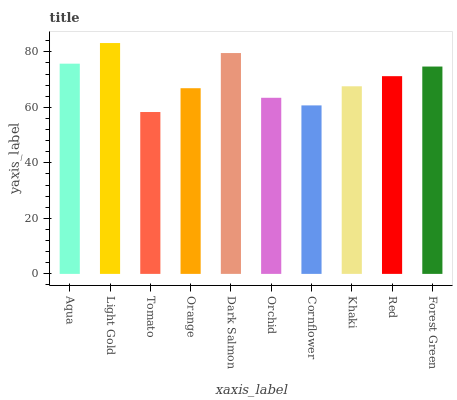Is Tomato the minimum?
Answer yes or no. Yes. Is Light Gold the maximum?
Answer yes or no. Yes. Is Light Gold the minimum?
Answer yes or no. No. Is Tomato the maximum?
Answer yes or no. No. Is Light Gold greater than Tomato?
Answer yes or no. Yes. Is Tomato less than Light Gold?
Answer yes or no. Yes. Is Tomato greater than Light Gold?
Answer yes or no. No. Is Light Gold less than Tomato?
Answer yes or no. No. Is Red the high median?
Answer yes or no. Yes. Is Khaki the low median?
Answer yes or no. Yes. Is Orchid the high median?
Answer yes or no. No. Is Forest Green the low median?
Answer yes or no. No. 